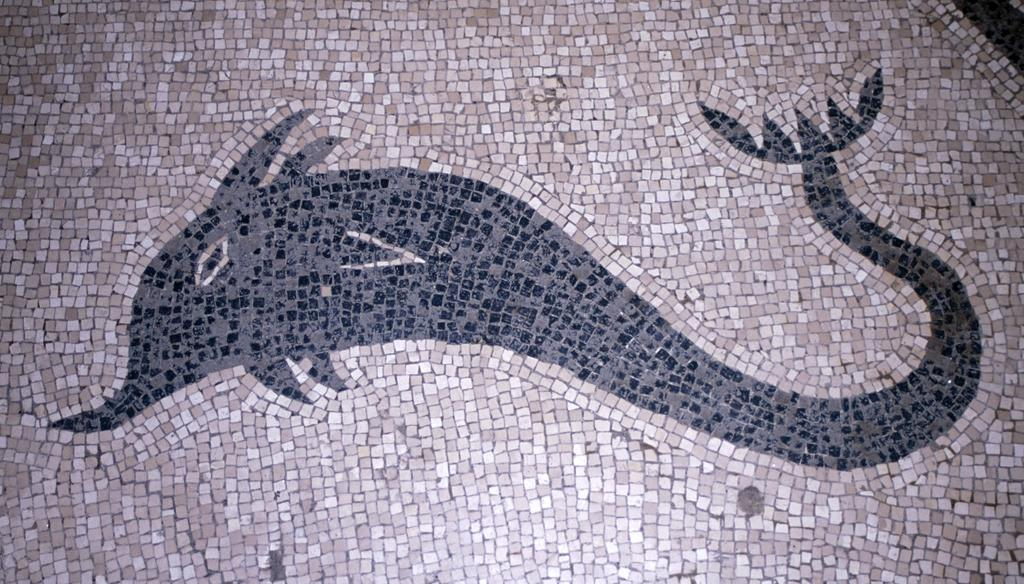What is depicted in the image? There is a picture of an animal in the image. Where is the picture of the animal located? The picture of the animal is on the floor. What type of ant can be seen performing an action on the border of the image? There are no ants present in the image, and the image does not have a border. 